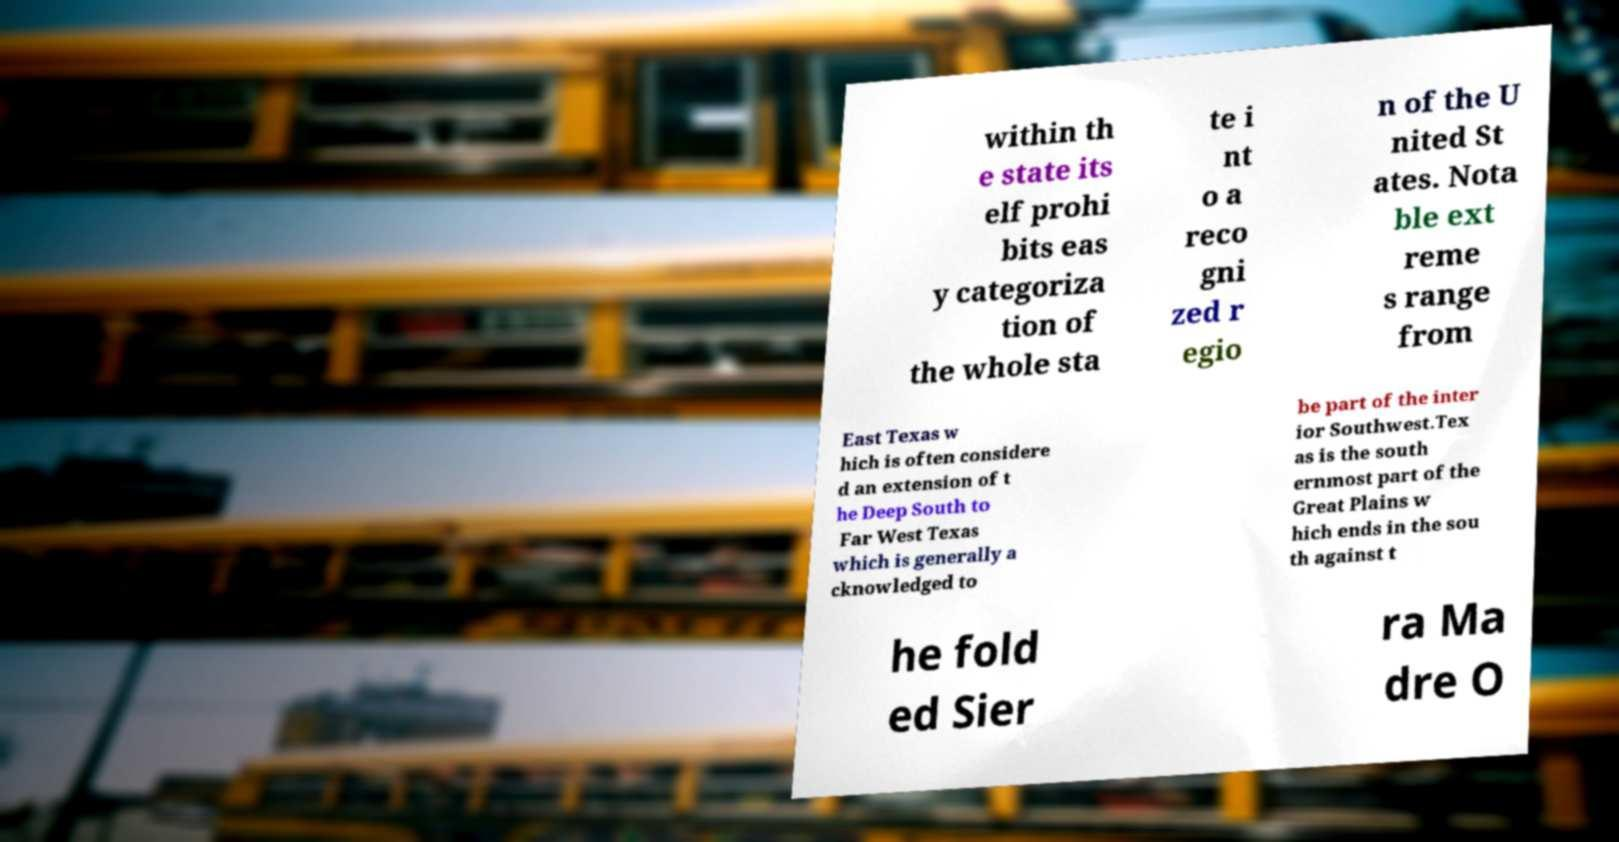Can you read and provide the text displayed in the image?This photo seems to have some interesting text. Can you extract and type it out for me? within th e state its elf prohi bits eas y categoriza tion of the whole sta te i nt o a reco gni zed r egio n of the U nited St ates. Nota ble ext reme s range from East Texas w hich is often considere d an extension of t he Deep South to Far West Texas which is generally a cknowledged to be part of the inter ior Southwest.Tex as is the south ernmost part of the Great Plains w hich ends in the sou th against t he fold ed Sier ra Ma dre O 